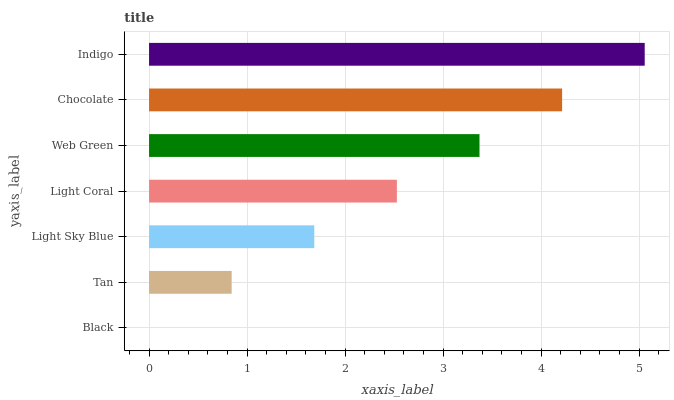Is Black the minimum?
Answer yes or no. Yes. Is Indigo the maximum?
Answer yes or no. Yes. Is Tan the minimum?
Answer yes or no. No. Is Tan the maximum?
Answer yes or no. No. Is Tan greater than Black?
Answer yes or no. Yes. Is Black less than Tan?
Answer yes or no. Yes. Is Black greater than Tan?
Answer yes or no. No. Is Tan less than Black?
Answer yes or no. No. Is Light Coral the high median?
Answer yes or no. Yes. Is Light Coral the low median?
Answer yes or no. Yes. Is Black the high median?
Answer yes or no. No. Is Light Sky Blue the low median?
Answer yes or no. No. 